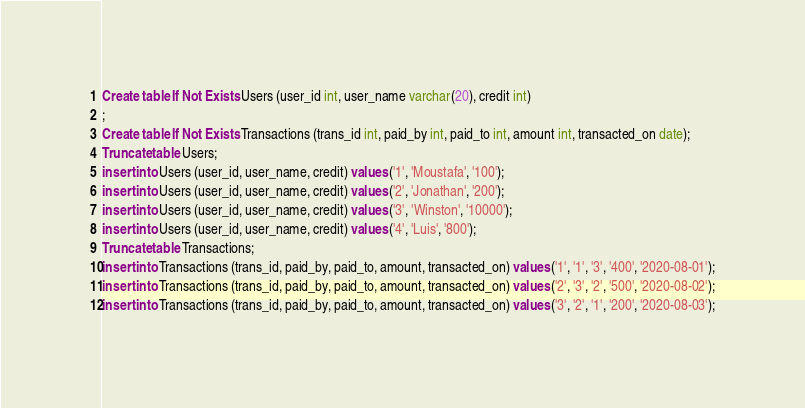Convert code to text. <code><loc_0><loc_0><loc_500><loc_500><_SQL_>Create table If Not Exists Users (user_id int, user_name varchar(20), credit int)
;
Create table If Not Exists Transactions (trans_id int, paid_by int, paid_to int, amount int, transacted_on date);
Truncate table Users;
insert into Users (user_id, user_name, credit) values ('1', 'Moustafa', '100');
insert into Users (user_id, user_name, credit) values ('2', 'Jonathan', '200');
insert into Users (user_id, user_name, credit) values ('3', 'Winston', '10000');
insert into Users (user_id, user_name, credit) values ('4', 'Luis', '800');
Truncate table Transactions;
insert into Transactions (trans_id, paid_by, paid_to, amount, transacted_on) values ('1', '1', '3', '400', '2020-08-01');
insert into Transactions (trans_id, paid_by, paid_to, amount, transacted_on) values ('2', '3', '2', '500', '2020-08-02');
insert into Transactions (trans_id, paid_by, paid_to, amount, transacted_on) values ('3', '2', '1', '200', '2020-08-03');
</code> 